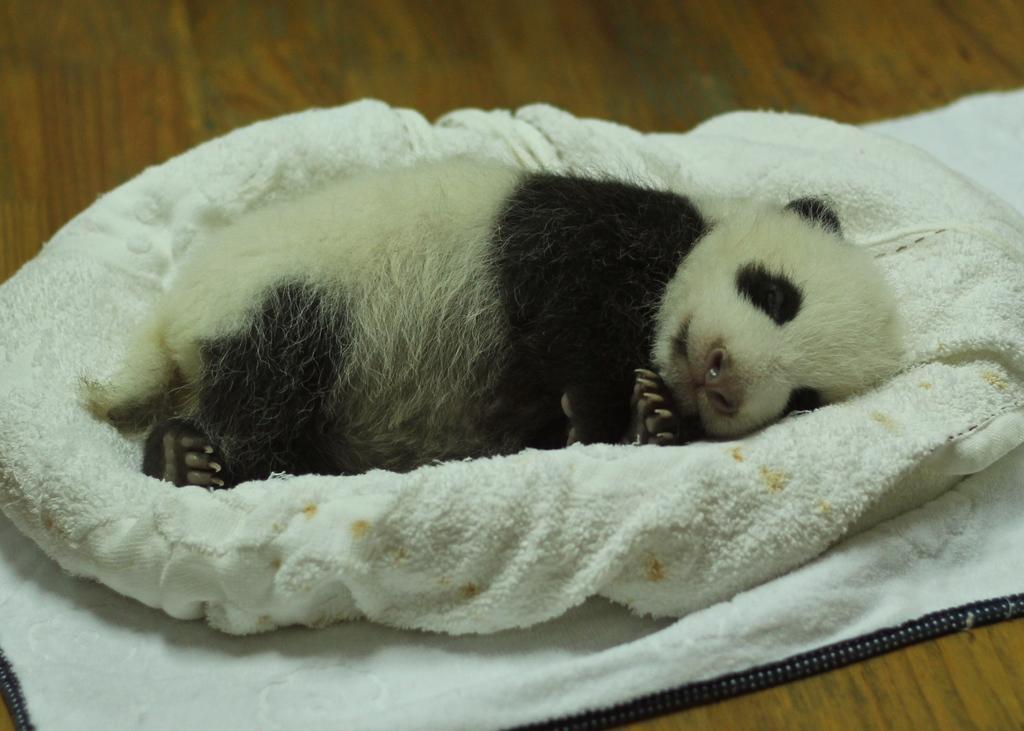Could you give a brief overview of what you see in this image? In this picture there is a white and black color small panda sleeping in the white cloth which is placed on the wooden table top. 